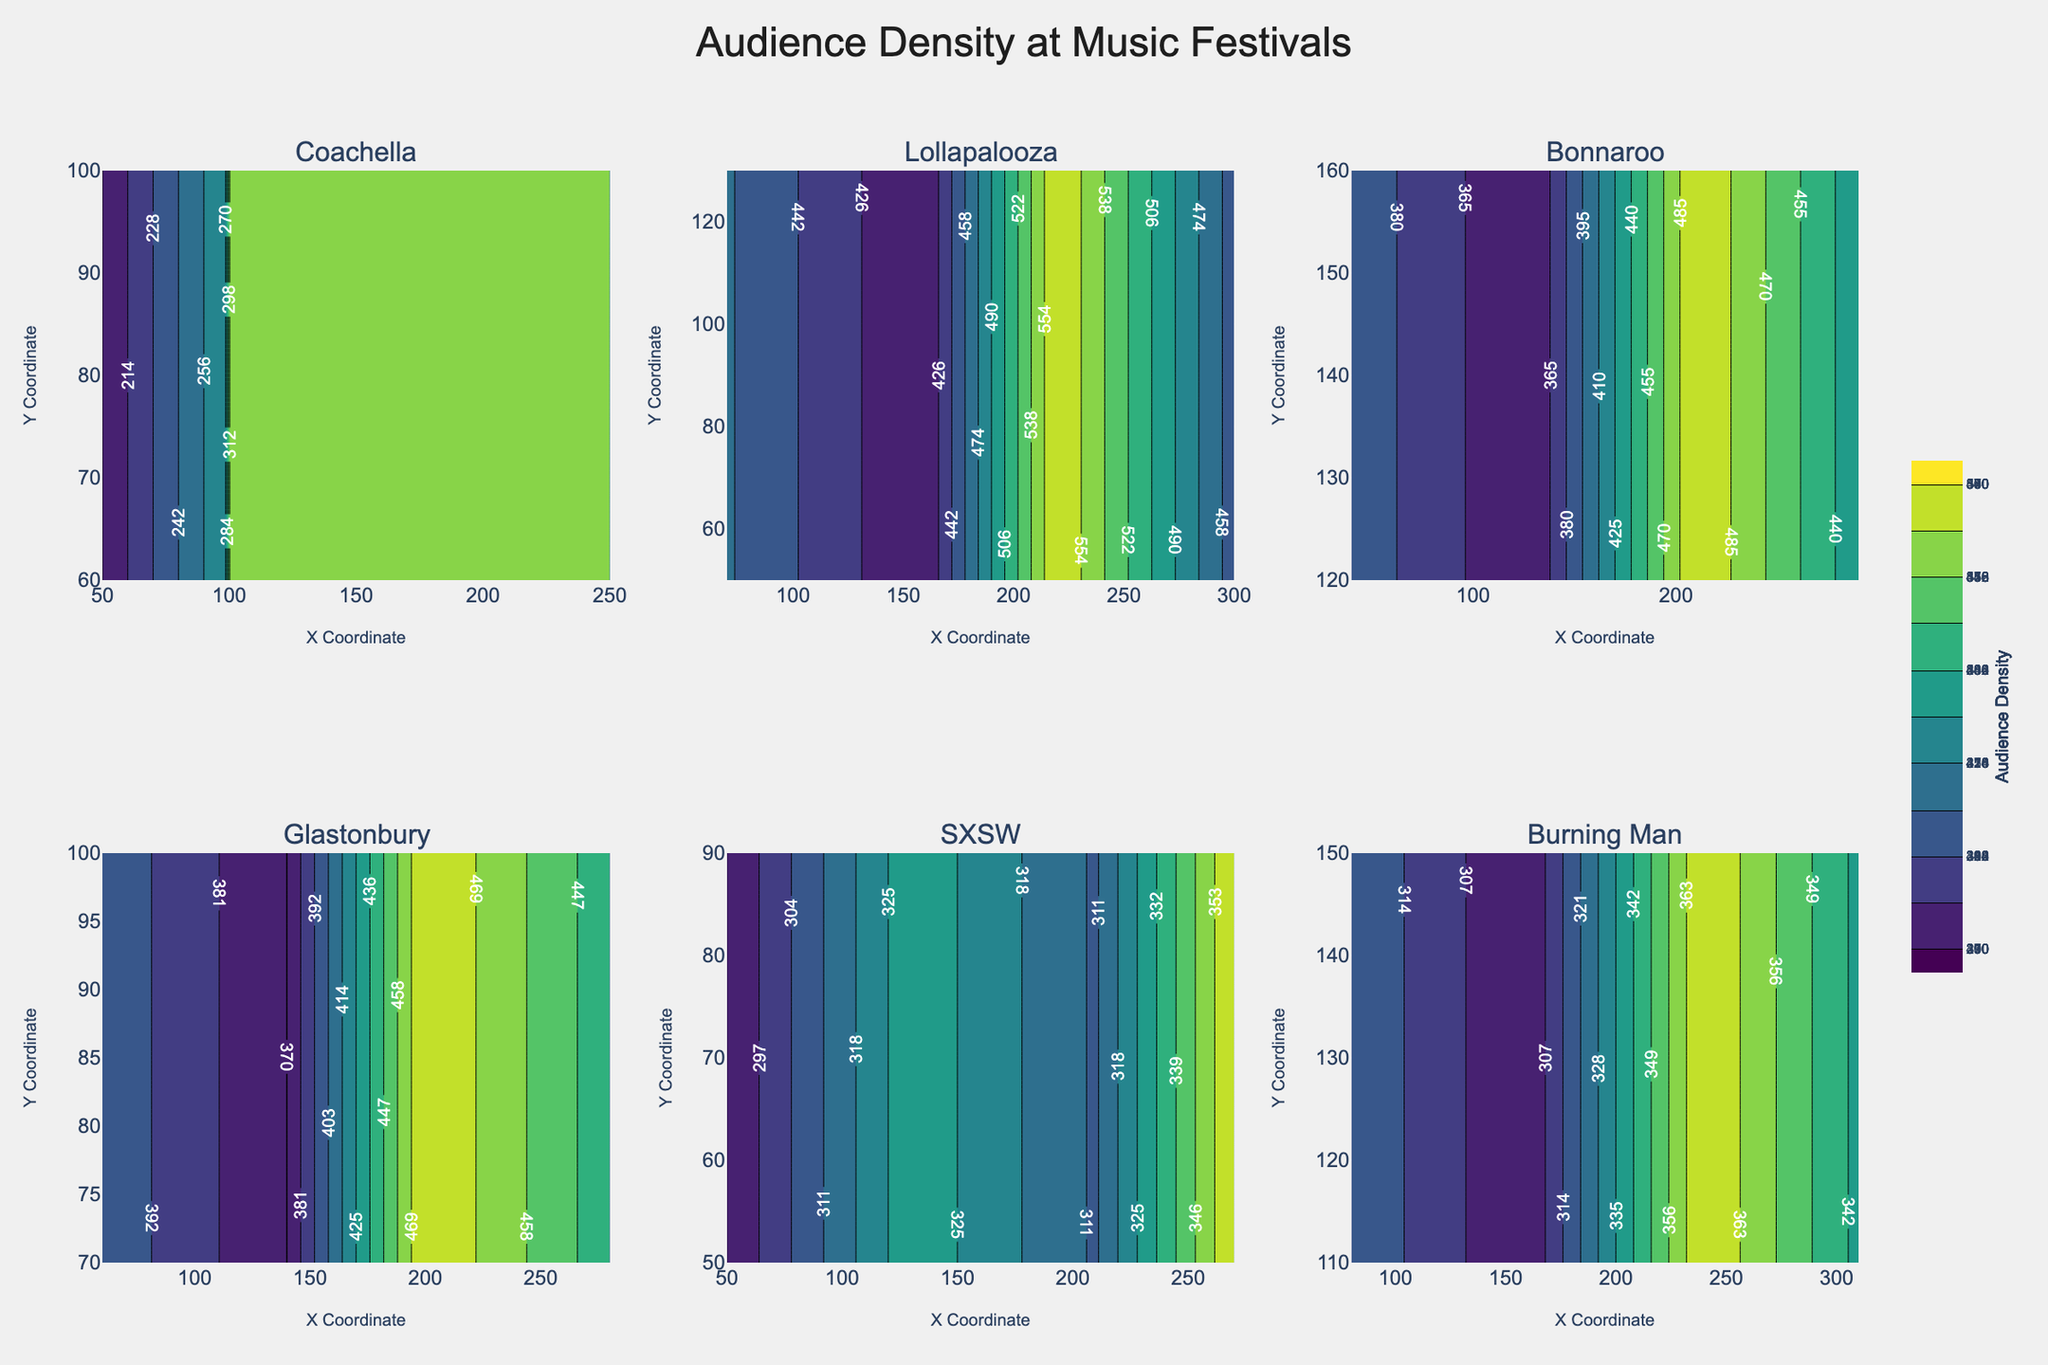What is the title of the figure? The title of the figure is found at the top and is usually descriptive of the content shown. From the given code, it is set by the layout parameter title. The title reads "Audience Density at Music Festivals".
Answer: Audience Density at Music Festivals Which festival has the highest audience density? To determine the festival with the highest audience density, locate the contour plot displaying the highest values in the color bar. From the given data and the contour specific to Chicago, it shows the highest density of 570.
Answer: Lollapalooza What are the x and y coordinates of the highest audience density at Coachella? To find the x and y coordinates with the highest density, look at the Coachella subplot and identify the peak value point. According to the provided data, the highest density for Coachella is 340, corresponding to x=150 and y=80.
Answer: 150, 80 Compare the average audience density between Coachella and Lollapalooza. Which one is higher? Calculate the average density for both festivals using the provided data. For Coachella: (200 + 340 + 290 + 320)/4 = 287.5. For Lollapalooza: (460 + 410 + 570 + 450)/4 = 472.5. Lollapalooza's average density is higher.
Answer: Lollapalooza Which coordinates at Glastonbury have the highest concentration of audience density? Locate the subplot for Glastonbury and identify the contour with the highest density. According to the data, Glastonbury's highest density is 480 at coordinates x=200 and y=90.
Answer: 200, 90 How does the audience density at coordinates (250, 70) at Coachella compare to the highest point at SXSW? Using the raw data, Coachella at (250, 70) has a density of 290, whereas the highest at SXSW is 360. Comparing these densities, SXSW has a higher value than the given coordinates of Coachella.
Answer: Lower What is the typical trend of audience density across the x-axis for Lollapalooza? Examine the trend by observing changes in density across the x-axis values in the Lollapalooza subplot. As x increases from 70 to 300, the audience density shows the highest values around the middle but then decreases towards the end.
Answer: Peaks in the middle and decreases How does the distribution of audience density at Burning Man compare with Bonnaroo? Observe both subplots, focusing on the density contours and their spread. Burning Man shows a more uniform distribution while Bonnaroo has a distinct peak.
Answer: Uniform vs. peak 